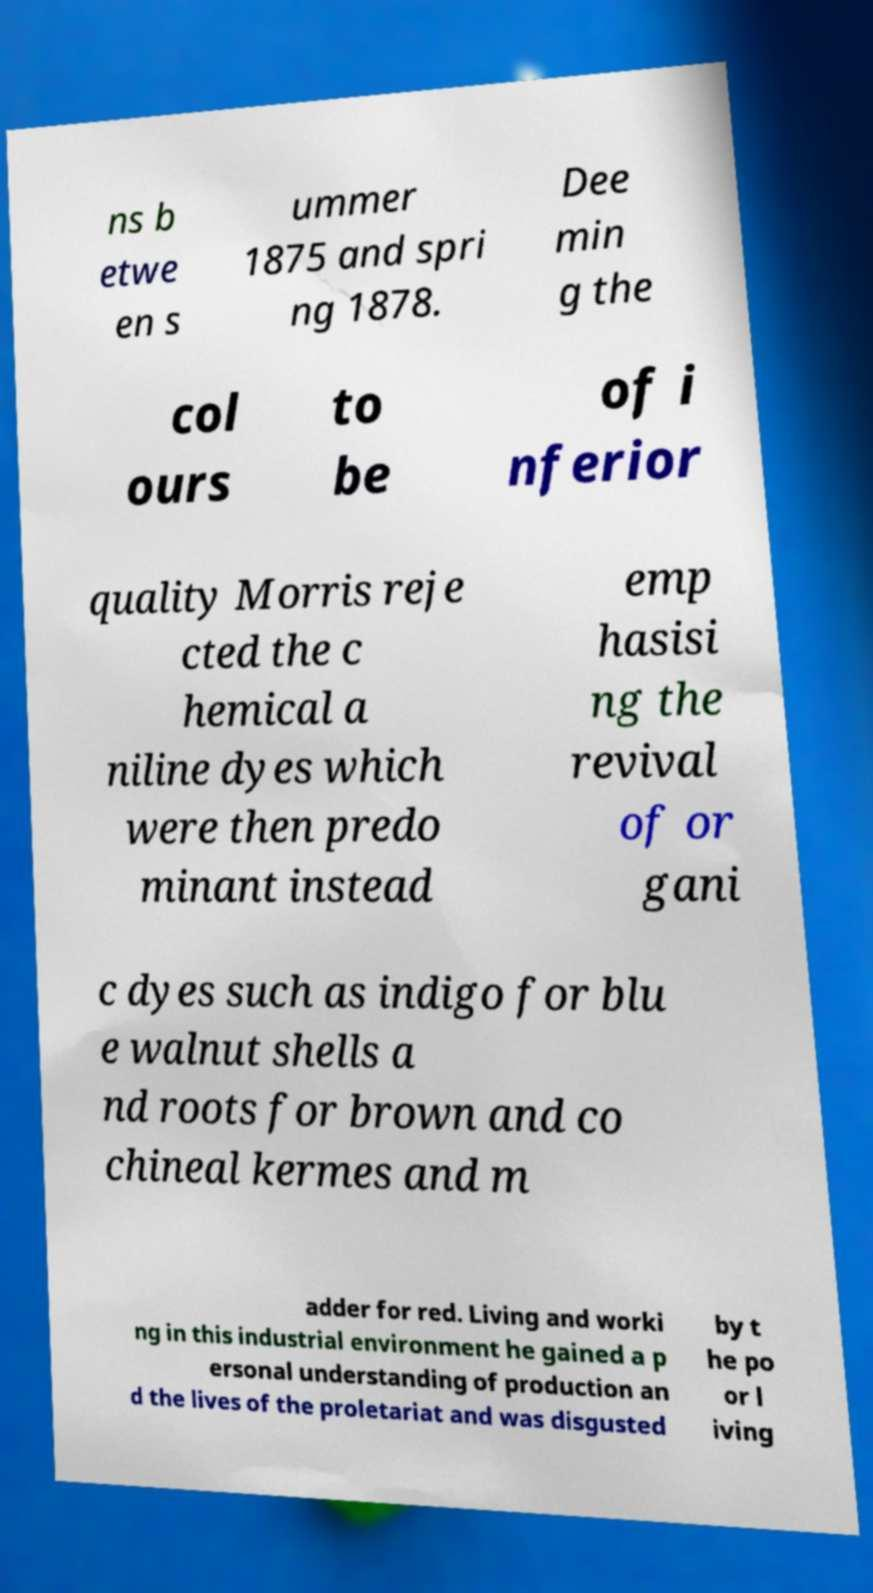Can you accurately transcribe the text from the provided image for me? ns b etwe en s ummer 1875 and spri ng 1878. Dee min g the col ours to be of i nferior quality Morris reje cted the c hemical a niline dyes which were then predo minant instead emp hasisi ng the revival of or gani c dyes such as indigo for blu e walnut shells a nd roots for brown and co chineal kermes and m adder for red. Living and worki ng in this industrial environment he gained a p ersonal understanding of production an d the lives of the proletariat and was disgusted by t he po or l iving 